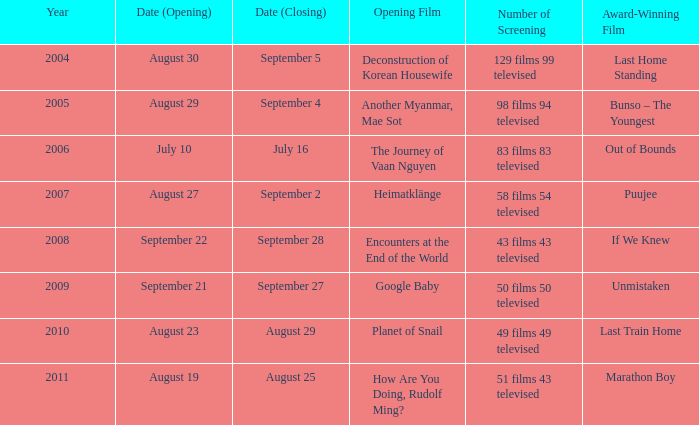How many number of screenings have an opening film of the journey of vaan nguyen? 1.0. 